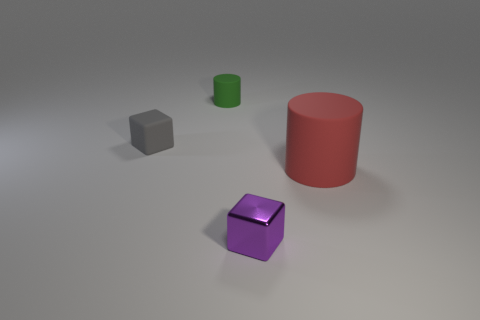There is a block that is in front of the tiny matte block; what is its material?
Your answer should be compact. Metal. The block that is left of the small green thing is what color?
Give a very brief answer. Gray. Do the cylinder that is behind the gray matte cube and the gray block have the same size?
Give a very brief answer. Yes. What is the size of the other rubber object that is the same shape as the green thing?
Your answer should be compact. Large. Is there any other thing that has the same size as the red rubber thing?
Provide a succinct answer. No. Is the shape of the big red rubber thing the same as the green object?
Provide a succinct answer. Yes. Is the number of large things in front of the big rubber cylinder less than the number of big red cylinders behind the purple metal object?
Your response must be concise. Yes. What number of small purple metallic objects are on the left side of the rubber cube?
Your answer should be very brief. 0. There is a small object in front of the large red object; is its shape the same as the tiny matte thing behind the gray object?
Provide a succinct answer. No. What number of other objects are the same color as the big matte cylinder?
Offer a very short reply. 0. 